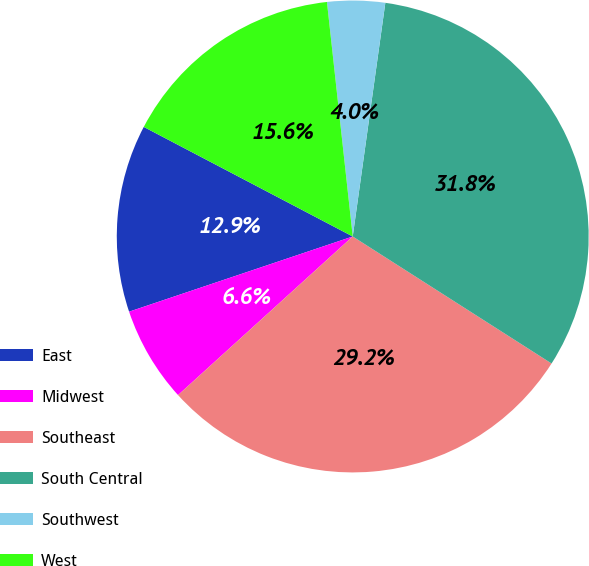Convert chart. <chart><loc_0><loc_0><loc_500><loc_500><pie_chart><fcel>East<fcel>Midwest<fcel>Southeast<fcel>South Central<fcel>Southwest<fcel>West<nl><fcel>12.85%<fcel>6.57%<fcel>29.22%<fcel>31.84%<fcel>3.95%<fcel>15.57%<nl></chart> 